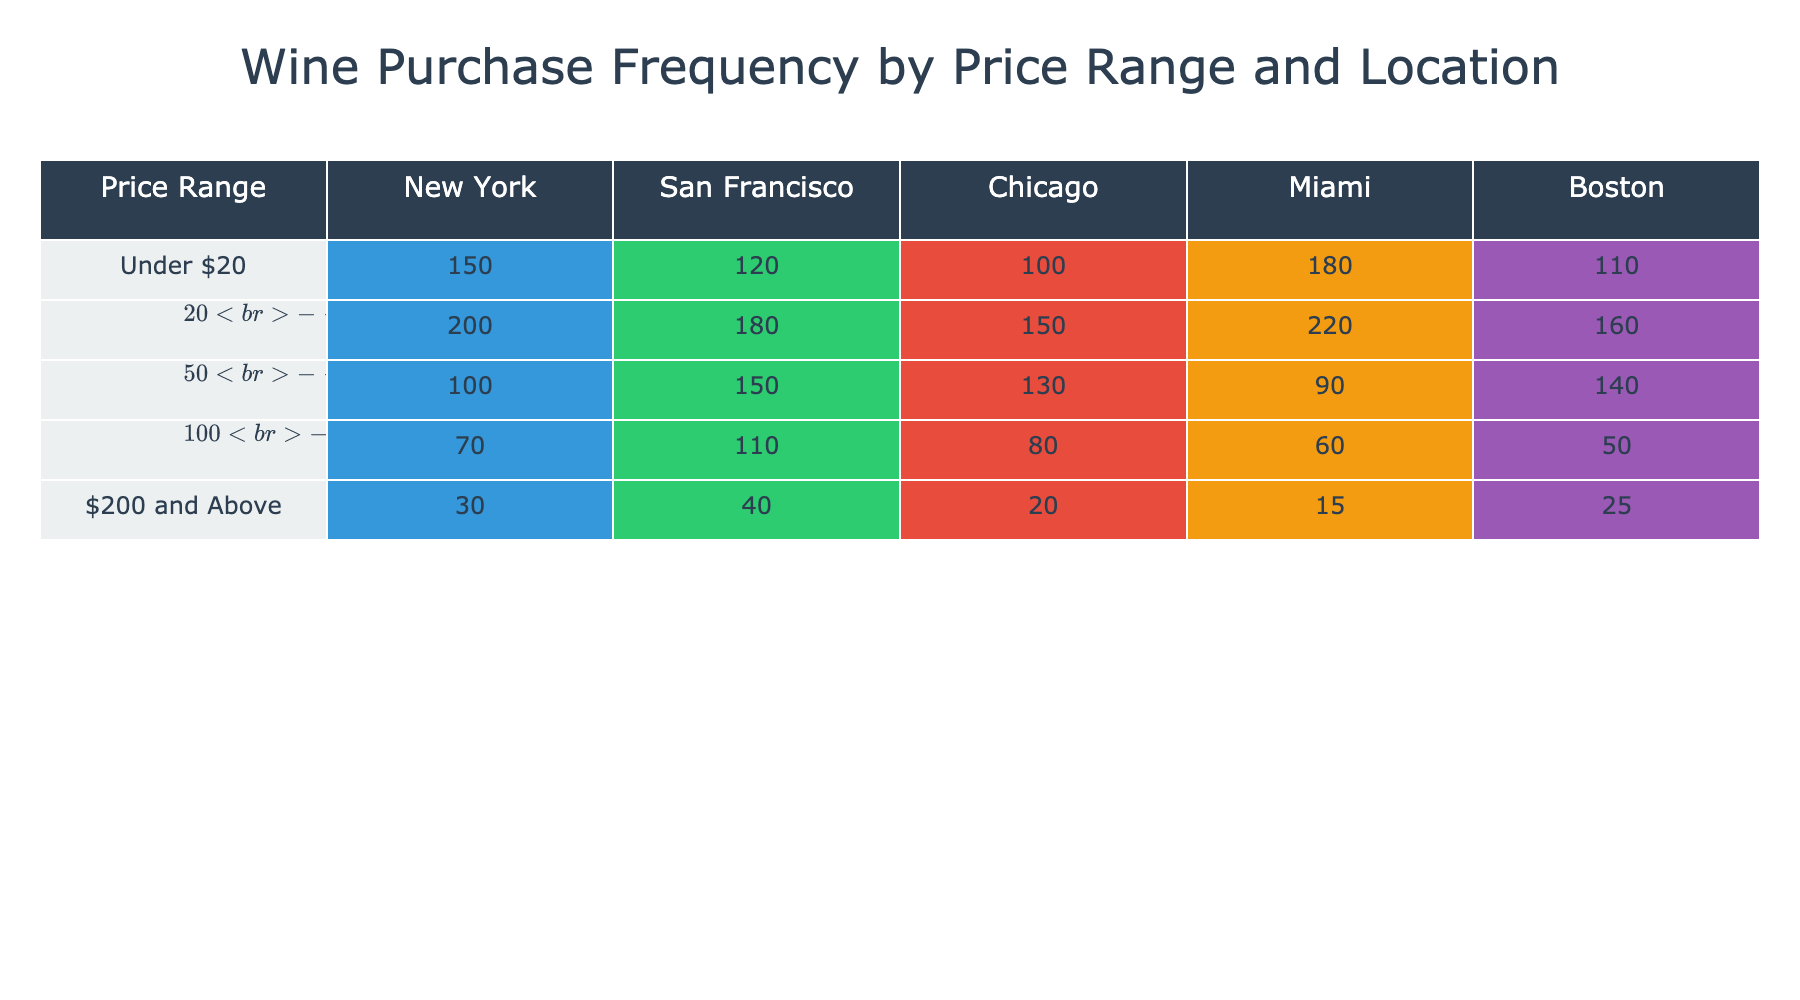What is the total frequency of wine purchases in New York across all price ranges? To find the total frequency in New York, sum the values under the "New York" column: 150 (Under $20) + 200 ($20 - $49) + 100 ($50 - $99) + 70 ($100 - $199) + 30 ($200 and Above) = 550.
Answer: 550 Which price range has the highest purchase frequency in Miami? Looking at the "Miami" column, the values are: 180 (Under $20), 220 ($20 - $49), 90 ($50 - $99), 60 ($100 - $199), 15 ($200 and Above). The highest is 220 from the $20 - $49 range.
Answer: $20 - $49 Is San Francisco's purchase frequency for the $50 - $99 price range greater than that for New York? San Francisco has 150 for the $50 - $99 range, while New York has 100. Since 150 is greater than 100, the answer is yes.
Answer: Yes What is the average frequency of wine purchases in Chicago across all price ranges? To find the average, sum the frequencies in Chicago: 100 (Under $20) + 150 ($20 - $49) + 130 ($50 - $99) + 80 ($100 - $199) + 20 ($200 and Above) = 480. There are 5 price ranges, so the average is 480/5 = 96.
Answer: 96 Which city has the lowest total wine purchase frequency, and what is that total? Calculate the total for each city: New York = 550, San Francisco = 580, Chicago = 480, Miami = 565, Boston = 455. The lowest is Boston with a total of 455.
Answer: Boston, 455 What is the difference in frequency of wine purchases for the $100 - $199 price range between New York and Miami? In New York, the frequency is 70, and in Miami, it is 60. The difference is 70 - 60 = 10.
Answer: 10 Is it true that the frequency for the "Under $20" price range is higher in Boston than in Chicago? Looking at the values, Boston has 110 and Chicago has 100 for the "Under $20" range. Since 110 is indeed greater than 100, the answer is yes.
Answer: Yes What is the total frequency of wine purchases for all price ranges in all cities combined? To find the total, sum all the values in the table: 150 + 200 + 100 + 70 + 30 (New York) + 120 + 180 + 150 + 110 + 40 (San Francisco) + 100 + 130 + 80 + 20 (Chicago) + 180 + 220 + 90 + 60 + 15 (Miami) + 110 + 160 + 140 + 50 + 25 (Boston) = 1860.
Answer: 1860 